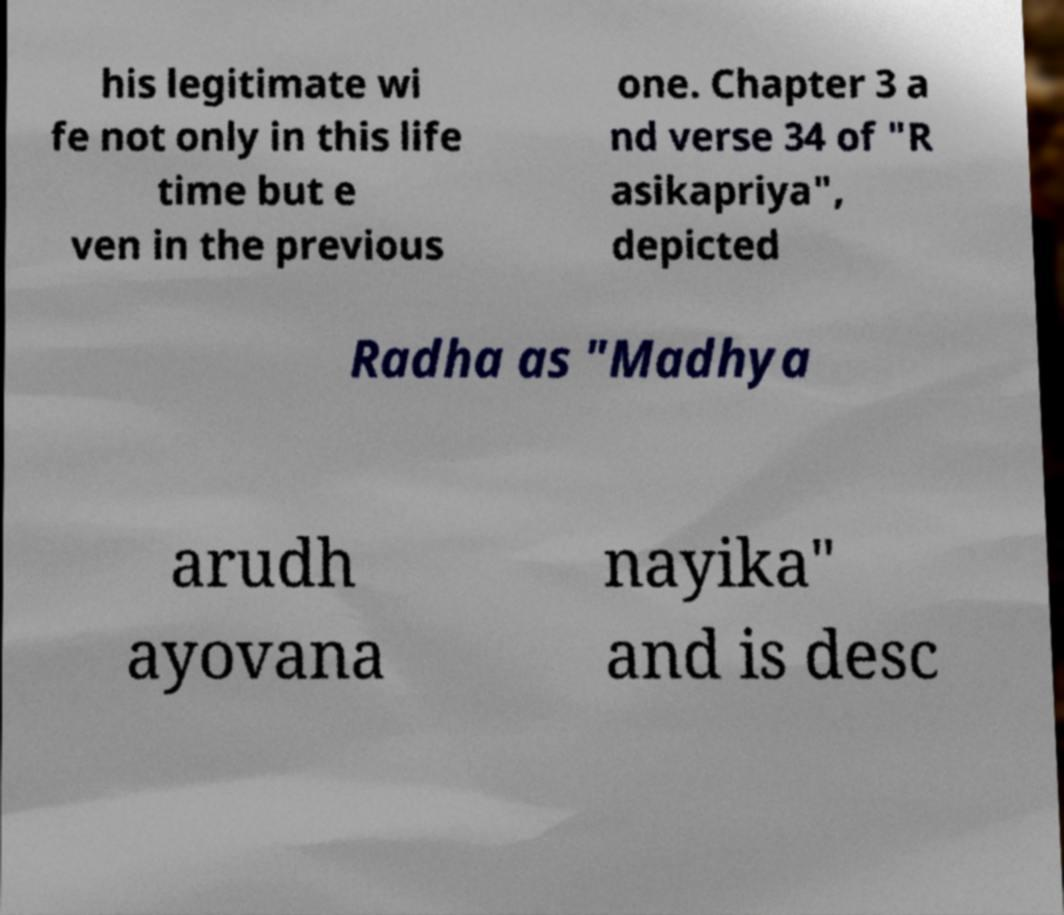What messages or text are displayed in this image? I need them in a readable, typed format. his legitimate wi fe not only in this life time but e ven in the previous one. Chapter 3 a nd verse 34 of "R asikapriya", depicted Radha as "Madhya arudh ayovana nayika" and is desc 